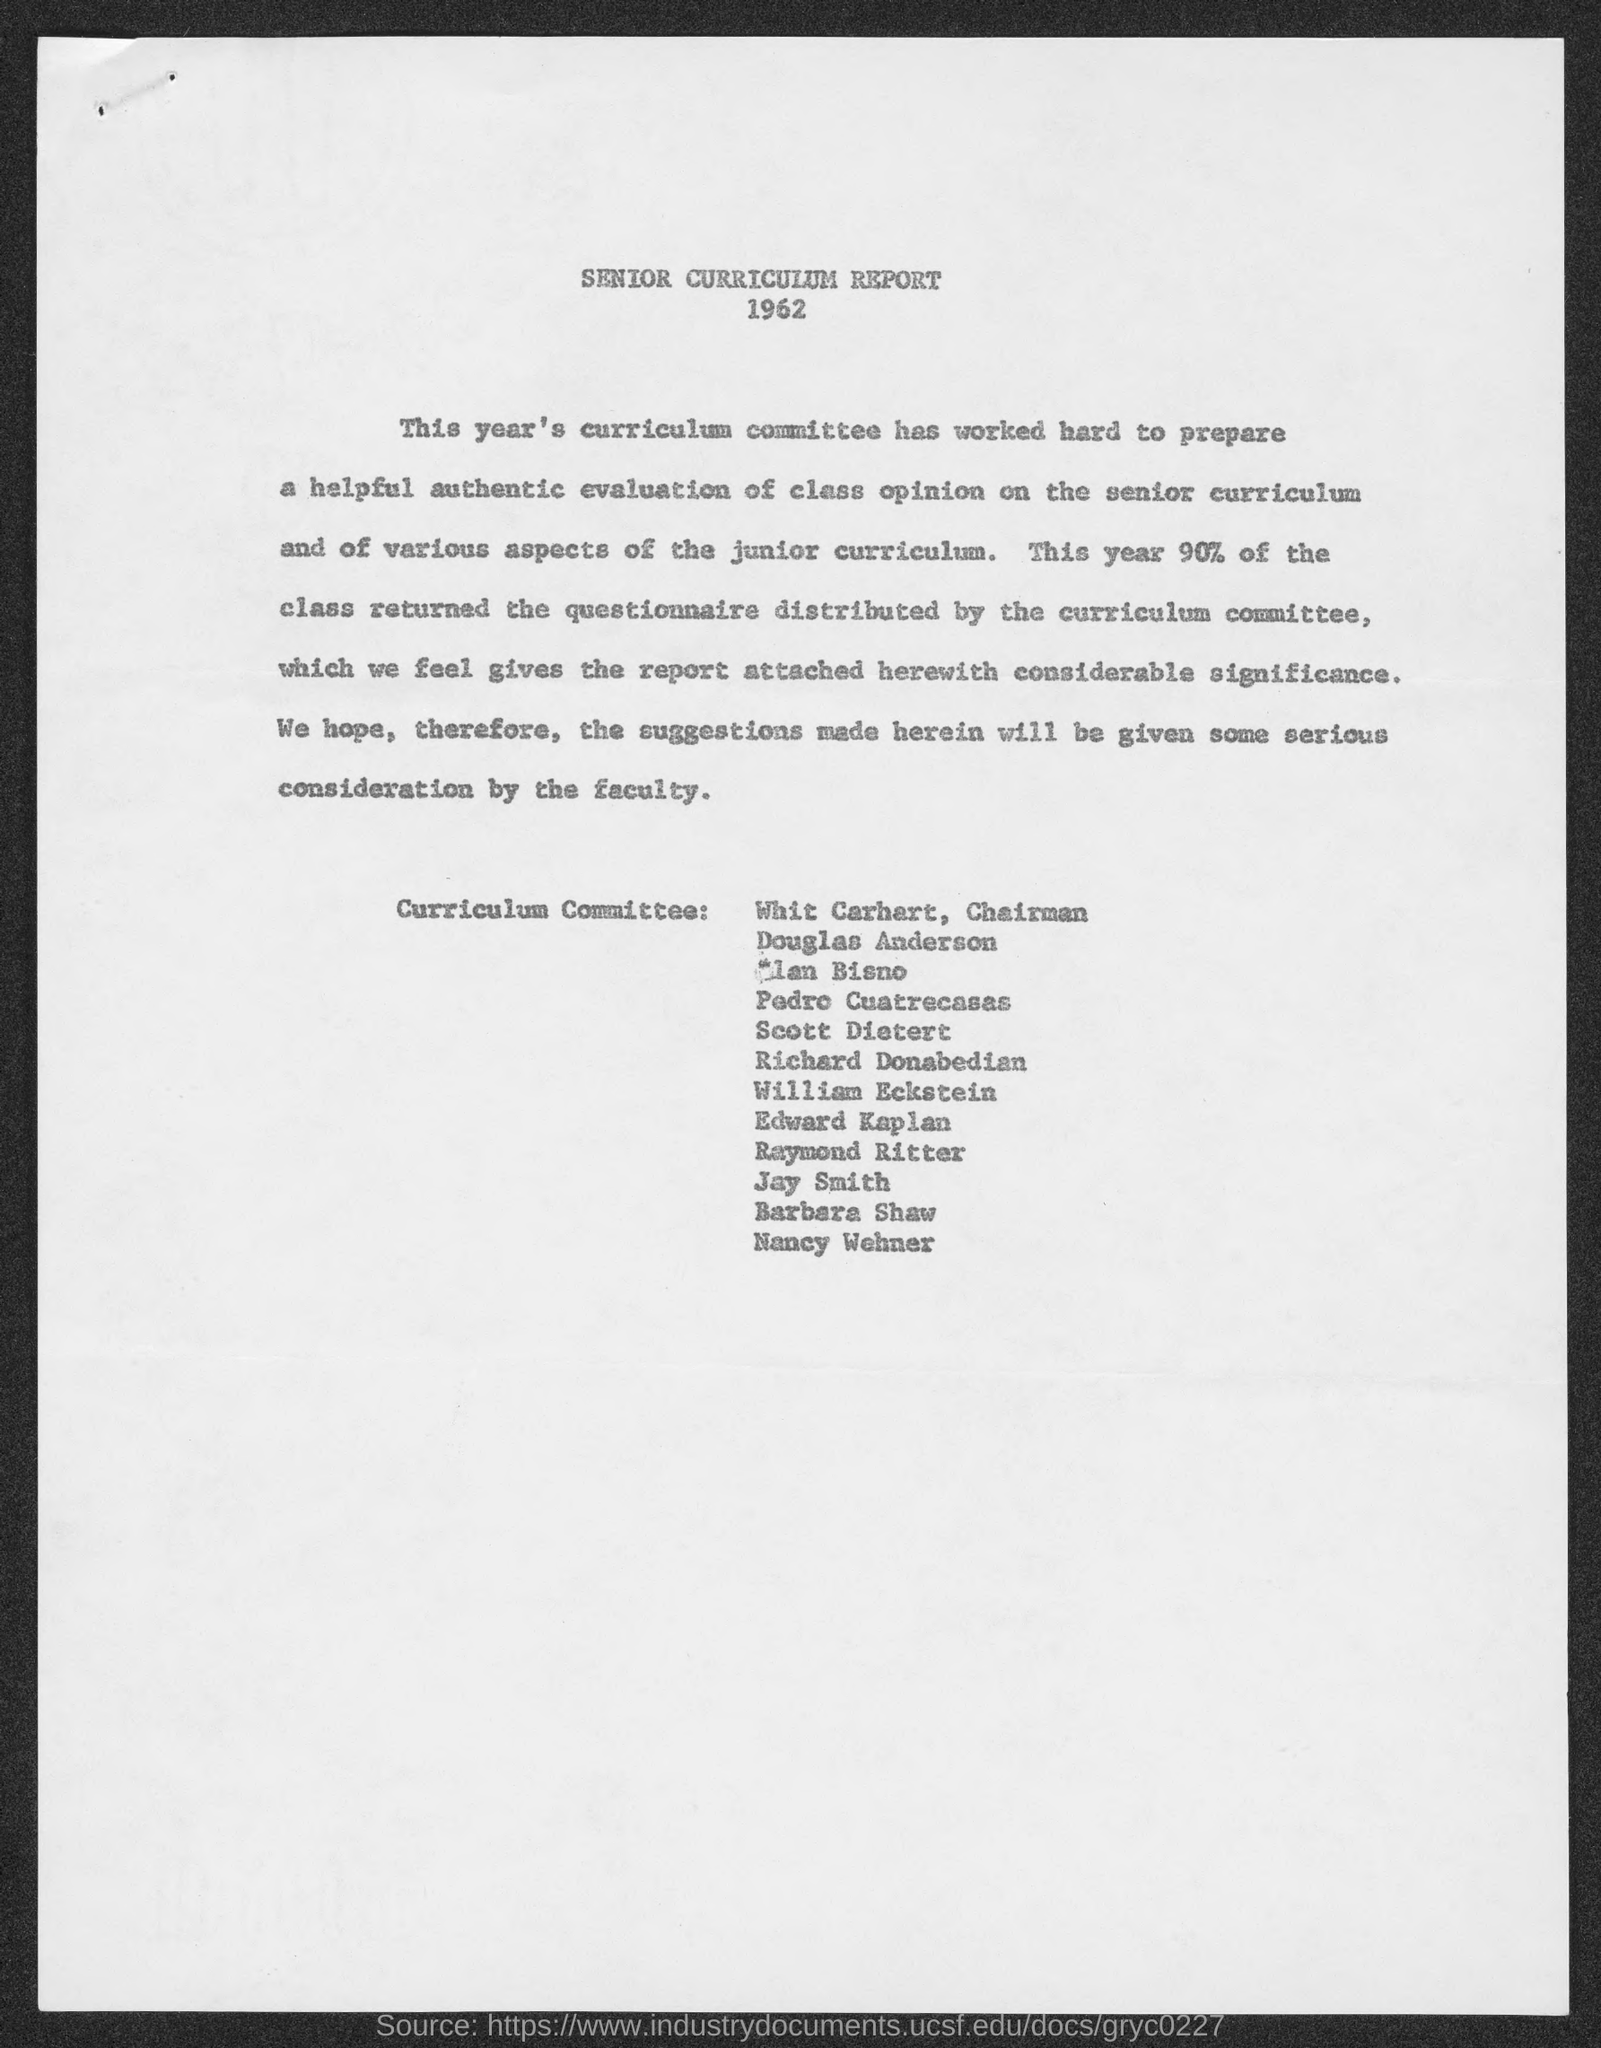Who is the chairman of curriculum committee?
Your answer should be very brief. Whit Carhart. 